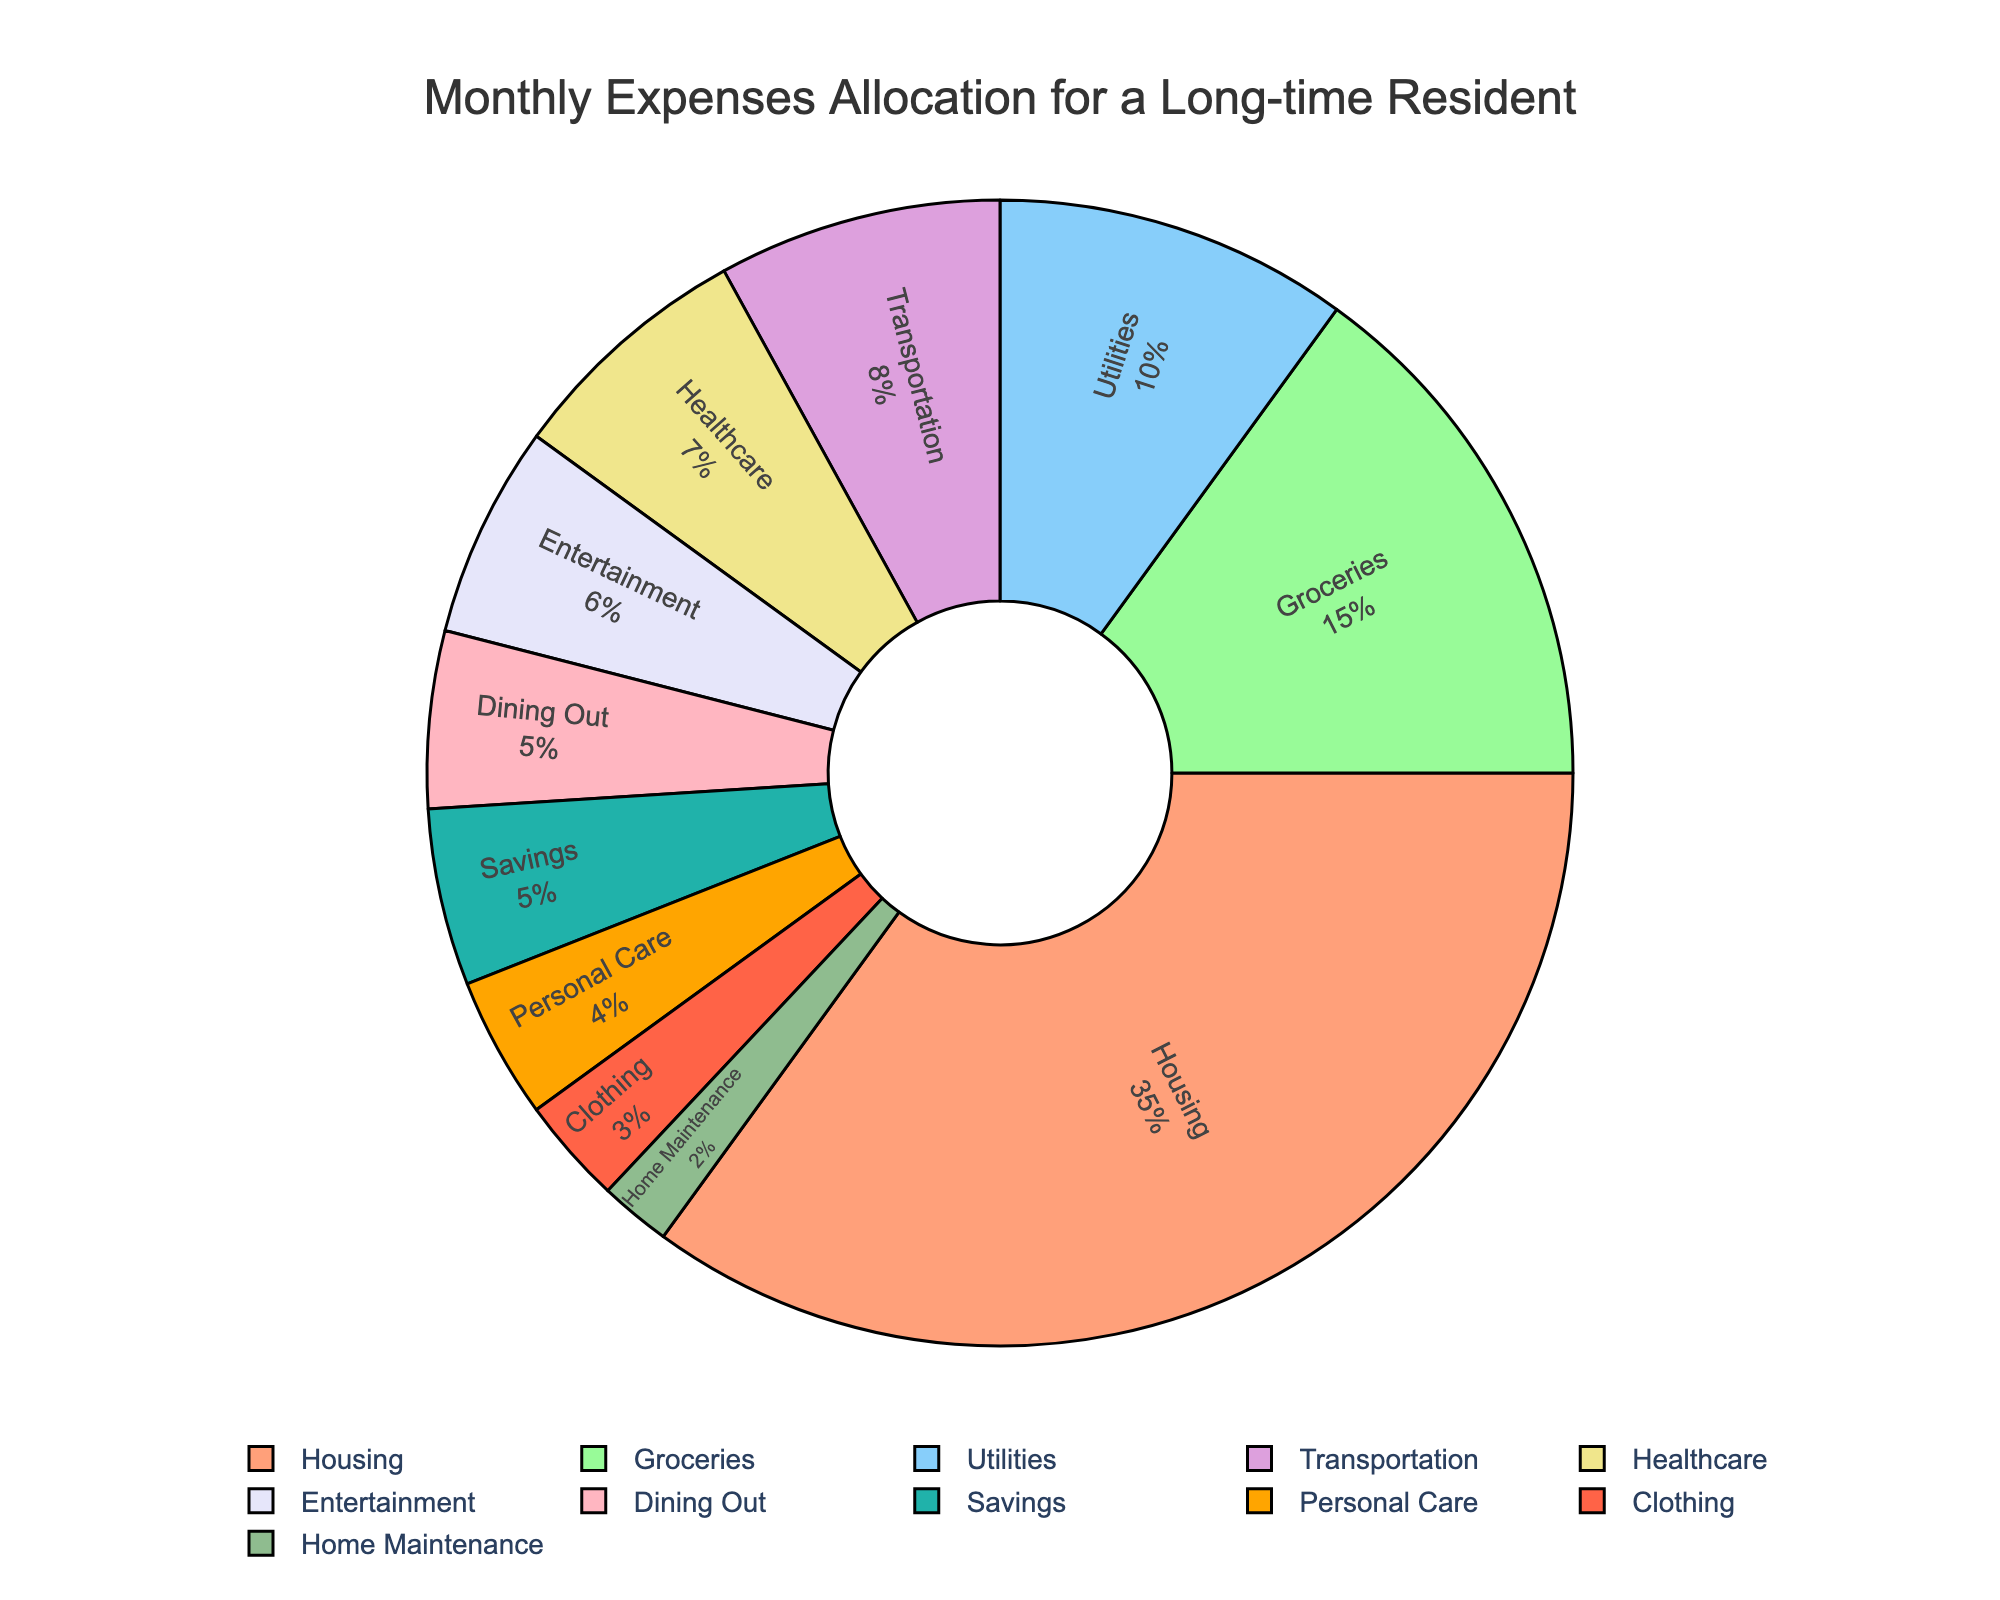What percentage of the monthly expenses is allocated to entertainment and dining out combined? To find the combined percentage, add the individual percentages of entertainment (6%) and dining out (5%) together: 6 + 5 = 11
Answer: 11 Which category has the smallest allocation of monthly expenses? Look at the pie chart and identify that home maintenance has the smallest slice of the pie, with an allocation of 2%
Answer: Home Maintenance Does the allocation for healthcare expenses exceed that for transportation? Compare the percentages for healthcare (7%) and transportation (8%) from the pie chart and see that healthcare is less than transportation.
Answer: No What is the total percentage allocation for housing, groceries, and utilities? Sum the percentages of housing (35%), groceries (15%), and utilities (10%): 35 + 15 + 10 = 60
Answer: 60 Are the expenses for personal care greater than for clothing? Compare the percentages for personal care (4%) and clothing (3%) and notice that personal care has a higher percentage.
Answer: Yes What is the combined allocation percentage for savings and clothing? Add the percentages for savings (5%) and clothing (3%): 5 + 3 = 8
Answer: 8 Which category's slice in the pie chart is colored in light blue? Identify the color associated with 'groceries' in the pie chart is light blue.
Answer: Groceries What percentage of the total expenses is dedicated to utilities and personal care together, and how much more is it compared to healthcare? Add utilities (10%) and personal care (4%) to get the combined percentage (10 + 4 = 14). Subtract healthcare’s percentage (7%) from this combined percentage (14 - 7 = 7).
Answer: 14, 7 Which category has a larger allocation: dining out or home maintenance? Compare the percentages: dining out (5%) and home maintenance (2%) and see that dining out has a larger allocation.
Answer: Dining Out What is the difference in allocation percentage between transportation and clothing? Subtract the percentage for clothing (3%) from transportation (8%): 8 - 3 = 5
Answer: 5 